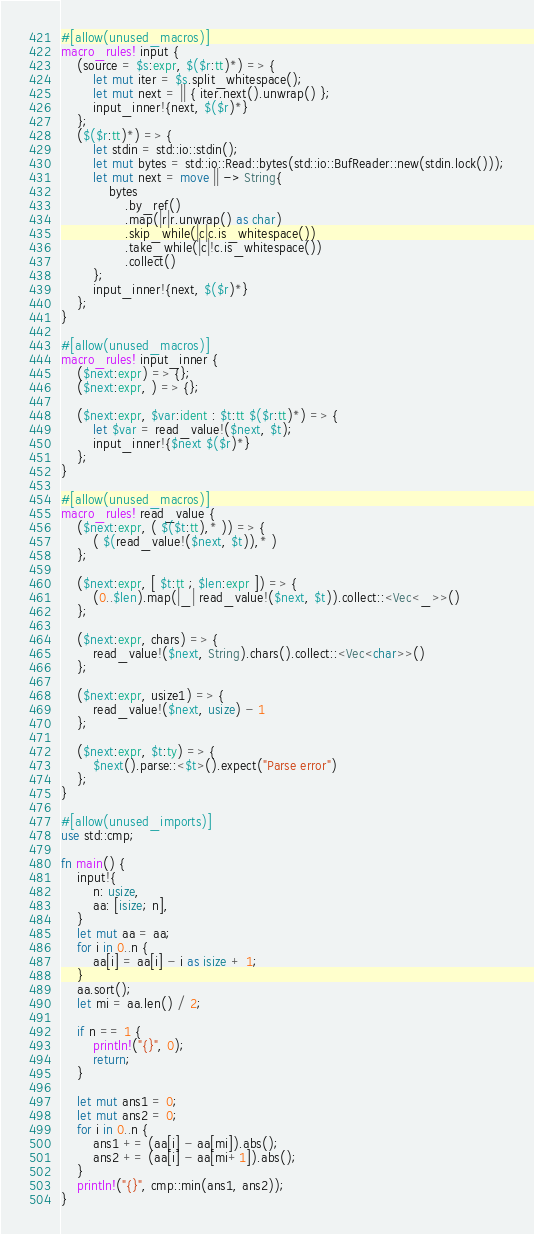Convert code to text. <code><loc_0><loc_0><loc_500><loc_500><_Rust_>#[allow(unused_macros)]
macro_rules! input {
    (source = $s:expr, $($r:tt)*) => {
        let mut iter = $s.split_whitespace();
        let mut next = || { iter.next().unwrap() };
        input_inner!{next, $($r)*}
    };
    ($($r:tt)*) => {
        let stdin = std::io::stdin();
        let mut bytes = std::io::Read::bytes(std::io::BufReader::new(stdin.lock()));
        let mut next = move || -> String{
            bytes
                .by_ref()
                .map(|r|r.unwrap() as char)
                .skip_while(|c|c.is_whitespace())
                .take_while(|c|!c.is_whitespace())
                .collect()
        };
        input_inner!{next, $($r)*}
    };
}

#[allow(unused_macros)]
macro_rules! input_inner {
    ($next:expr) => {};
    ($next:expr, ) => {};

    ($next:expr, $var:ident : $t:tt $($r:tt)*) => {
        let $var = read_value!($next, $t);
        input_inner!{$next $($r)*}
    };
}

#[allow(unused_macros)]
macro_rules! read_value {
    ($next:expr, ( $($t:tt),* )) => {
        ( $(read_value!($next, $t)),* )
    };

    ($next:expr, [ $t:tt ; $len:expr ]) => {
        (0..$len).map(|_| read_value!($next, $t)).collect::<Vec<_>>()
    };

    ($next:expr, chars) => {
        read_value!($next, String).chars().collect::<Vec<char>>()
    };

    ($next:expr, usize1) => {
        read_value!($next, usize) - 1
    };

    ($next:expr, $t:ty) => {
        $next().parse::<$t>().expect("Parse error")
    };
}

#[allow(unused_imports)]
use std::cmp;

fn main() {
    input!{
        n: usize,
        aa: [isize; n],
    }
    let mut aa = aa;
    for i in 0..n {
        aa[i] = aa[i] - i as isize + 1;
    }
    aa.sort();
    let mi = aa.len() / 2;

    if n == 1 {
        println!("{}", 0);
        return;
    }

    let mut ans1 = 0;
    let mut ans2 = 0;
    for i in 0..n {
        ans1 += (aa[i] - aa[mi]).abs();
        ans2 += (aa[i] - aa[mi+1]).abs();
    }
    println!("{}", cmp::min(ans1, ans2));
}
</code> 